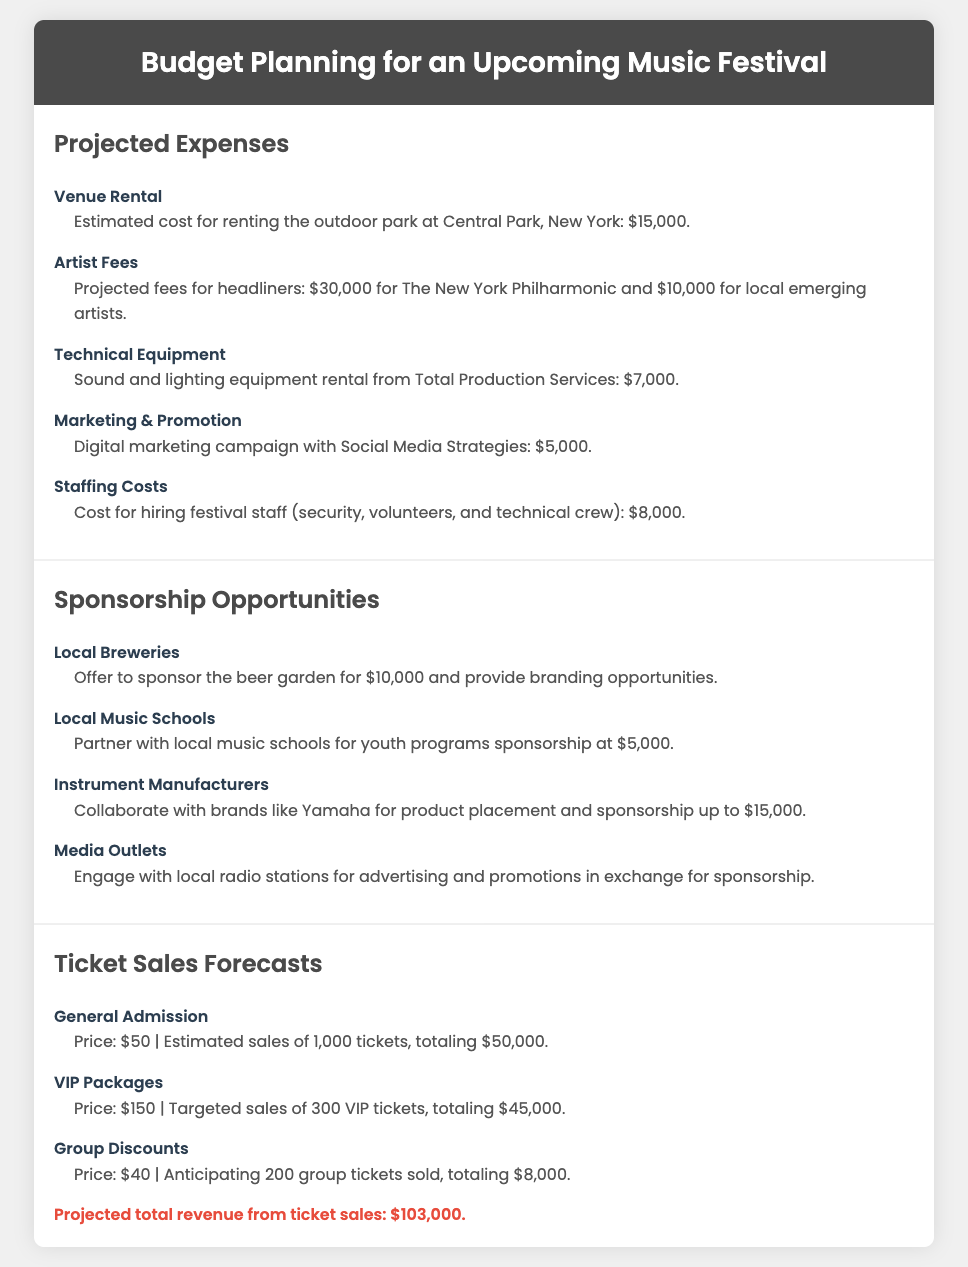what is the estimated cost for venue rental? The document states the estimated cost for renting the outdoor park at Central Park, New York, is $15,000.
Answer: $15,000 how much are the artist fees for The New York Philharmonic? The projected fees for The New York Philharmonic are specified in the document as $30,000.
Answer: $30,000 what is the total projected revenue from ticket sales? The document summarizes the total projected revenue from ticket sales, which is calculated from general admission, VIP packages, and group discounts.
Answer: $103,000 who are the local music schools sponsoring? The document mentions that local music schools can partner for youth programs sponsorship.
Answer: local music schools how much does it cost for staffing at the festival? The document details the cost for hiring festival staff, which amounts to $8,000.
Answer: $8,000 what is one sponsorship opportunity mentioned in the document? The document lists several sponsorship opportunities and one example is local breweries offering to sponsor the beer garden.
Answer: local breweries what is the price of a VIP package ticket? The document indicates that the price for a VIP package ticket is $150.
Answer: $150 how many general admission tickets are estimated to be sold? The document estimates that 1,000 general admission tickets will be sold.
Answer: 1,000 what is the anticipated revenue from group discounts? The document states that group discounts are expected to generate $8,000 in revenue.
Answer: $8,000 